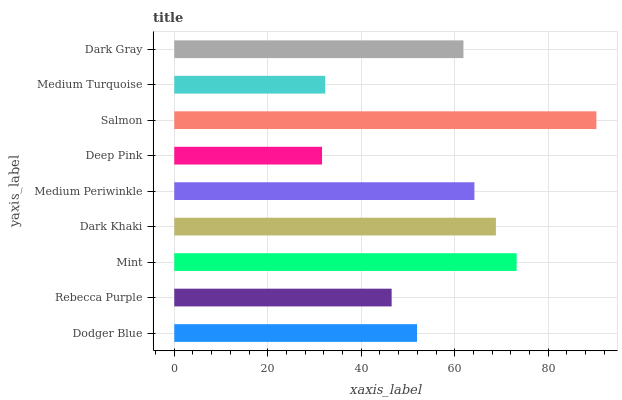Is Deep Pink the minimum?
Answer yes or no. Yes. Is Salmon the maximum?
Answer yes or no. Yes. Is Rebecca Purple the minimum?
Answer yes or no. No. Is Rebecca Purple the maximum?
Answer yes or no. No. Is Dodger Blue greater than Rebecca Purple?
Answer yes or no. Yes. Is Rebecca Purple less than Dodger Blue?
Answer yes or no. Yes. Is Rebecca Purple greater than Dodger Blue?
Answer yes or no. No. Is Dodger Blue less than Rebecca Purple?
Answer yes or no. No. Is Dark Gray the high median?
Answer yes or no. Yes. Is Dark Gray the low median?
Answer yes or no. Yes. Is Salmon the high median?
Answer yes or no. No. Is Rebecca Purple the low median?
Answer yes or no. No. 